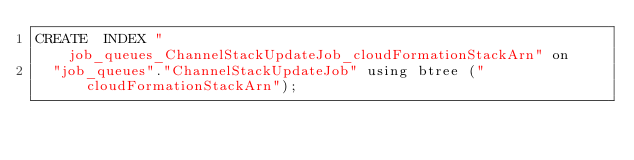Convert code to text. <code><loc_0><loc_0><loc_500><loc_500><_SQL_>CREATE  INDEX "job_queues_ChannelStackUpdateJob_cloudFormationStackArn" on
  "job_queues"."ChannelStackUpdateJob" using btree ("cloudFormationStackArn");
</code> 